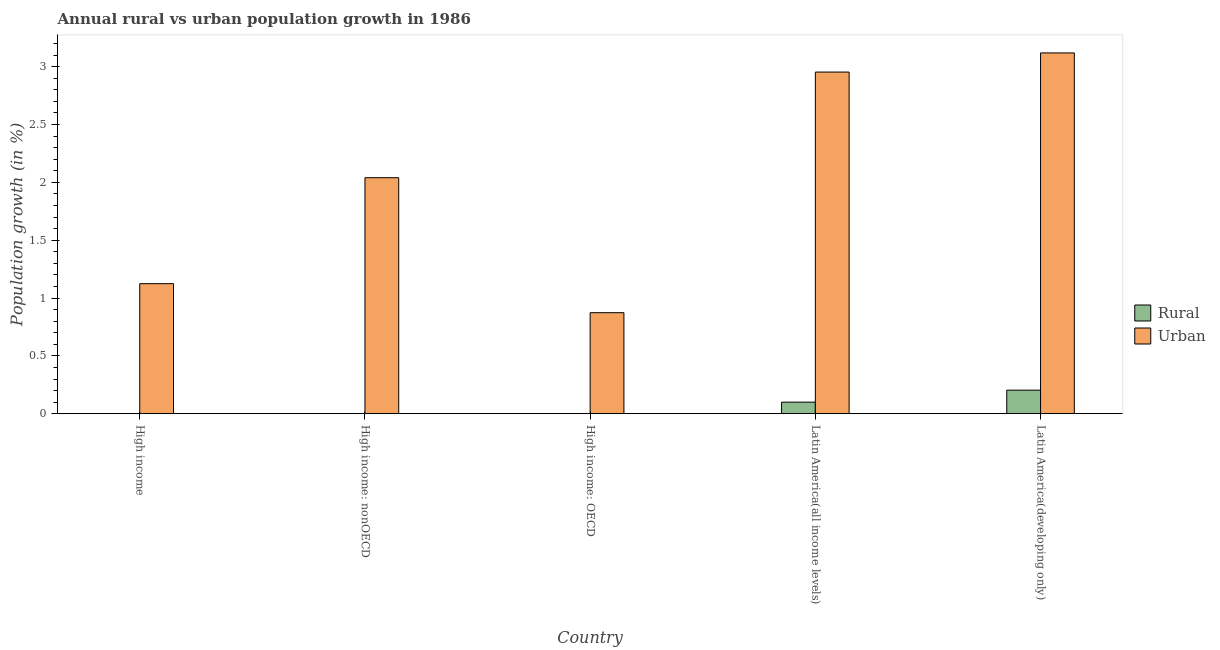How many different coloured bars are there?
Your response must be concise. 2. Are the number of bars on each tick of the X-axis equal?
Make the answer very short. No. How many bars are there on the 3rd tick from the right?
Keep it short and to the point. 1. What is the label of the 4th group of bars from the left?
Your response must be concise. Latin America(all income levels). In how many cases, is the number of bars for a given country not equal to the number of legend labels?
Offer a terse response. 3. What is the rural population growth in High income: OECD?
Offer a very short reply. 0. Across all countries, what is the maximum rural population growth?
Keep it short and to the point. 0.2. Across all countries, what is the minimum urban population growth?
Offer a terse response. 0.87. In which country was the urban population growth maximum?
Your answer should be compact. Latin America(developing only). What is the total rural population growth in the graph?
Your response must be concise. 0.3. What is the difference between the urban population growth in Latin America(all income levels) and that in Latin America(developing only)?
Offer a terse response. -0.17. What is the difference between the rural population growth in Latin America(developing only) and the urban population growth in High income?
Keep it short and to the point. -0.92. What is the average rural population growth per country?
Provide a succinct answer. 0.06. What is the difference between the rural population growth and urban population growth in Latin America(developing only)?
Your answer should be very brief. -2.91. In how many countries, is the urban population growth greater than 1.6 %?
Ensure brevity in your answer.  3. What is the ratio of the urban population growth in Latin America(all income levels) to that in Latin America(developing only)?
Your answer should be very brief. 0.95. Is the urban population growth in High income less than that in Latin America(all income levels)?
Give a very brief answer. Yes. Is the difference between the urban population growth in Latin America(all income levels) and Latin America(developing only) greater than the difference between the rural population growth in Latin America(all income levels) and Latin America(developing only)?
Ensure brevity in your answer.  No. What is the difference between the highest and the second highest urban population growth?
Your answer should be compact. 0.17. What is the difference between the highest and the lowest rural population growth?
Your response must be concise. 0.2. Is the sum of the urban population growth in High income and Latin America(developing only) greater than the maximum rural population growth across all countries?
Ensure brevity in your answer.  Yes. How many bars are there?
Your answer should be compact. 7. Are all the bars in the graph horizontal?
Ensure brevity in your answer.  No. How many countries are there in the graph?
Give a very brief answer. 5. Are the values on the major ticks of Y-axis written in scientific E-notation?
Your response must be concise. No. Does the graph contain grids?
Offer a terse response. No. How many legend labels are there?
Keep it short and to the point. 2. How are the legend labels stacked?
Your response must be concise. Vertical. What is the title of the graph?
Offer a very short reply. Annual rural vs urban population growth in 1986. Does "Electricity" appear as one of the legend labels in the graph?
Provide a succinct answer. No. What is the label or title of the Y-axis?
Keep it short and to the point. Population growth (in %). What is the Population growth (in %) of Rural in High income?
Make the answer very short. 0. What is the Population growth (in %) of Urban  in High income?
Provide a succinct answer. 1.12. What is the Population growth (in %) in Urban  in High income: nonOECD?
Keep it short and to the point. 2.04. What is the Population growth (in %) of Urban  in High income: OECD?
Offer a terse response. 0.87. What is the Population growth (in %) in Rural in Latin America(all income levels)?
Offer a very short reply. 0.1. What is the Population growth (in %) of Urban  in Latin America(all income levels)?
Your answer should be very brief. 2.95. What is the Population growth (in %) of Rural in Latin America(developing only)?
Your answer should be compact. 0.2. What is the Population growth (in %) in Urban  in Latin America(developing only)?
Give a very brief answer. 3.12. Across all countries, what is the maximum Population growth (in %) of Rural?
Offer a terse response. 0.2. Across all countries, what is the maximum Population growth (in %) of Urban ?
Offer a terse response. 3.12. Across all countries, what is the minimum Population growth (in %) in Urban ?
Your answer should be compact. 0.87. What is the total Population growth (in %) in Rural in the graph?
Your answer should be compact. 0.3. What is the total Population growth (in %) of Urban  in the graph?
Give a very brief answer. 10.11. What is the difference between the Population growth (in %) of Urban  in High income and that in High income: nonOECD?
Your answer should be very brief. -0.92. What is the difference between the Population growth (in %) of Urban  in High income and that in High income: OECD?
Keep it short and to the point. 0.25. What is the difference between the Population growth (in %) in Urban  in High income and that in Latin America(all income levels)?
Offer a very short reply. -1.83. What is the difference between the Population growth (in %) in Urban  in High income and that in Latin America(developing only)?
Provide a short and direct response. -1.99. What is the difference between the Population growth (in %) in Urban  in High income: nonOECD and that in High income: OECD?
Offer a terse response. 1.17. What is the difference between the Population growth (in %) of Urban  in High income: nonOECD and that in Latin America(all income levels)?
Your answer should be very brief. -0.91. What is the difference between the Population growth (in %) in Urban  in High income: nonOECD and that in Latin America(developing only)?
Provide a short and direct response. -1.08. What is the difference between the Population growth (in %) of Urban  in High income: OECD and that in Latin America(all income levels)?
Provide a succinct answer. -2.08. What is the difference between the Population growth (in %) in Urban  in High income: OECD and that in Latin America(developing only)?
Your response must be concise. -2.25. What is the difference between the Population growth (in %) in Rural in Latin America(all income levels) and that in Latin America(developing only)?
Make the answer very short. -0.1. What is the difference between the Population growth (in %) in Urban  in Latin America(all income levels) and that in Latin America(developing only)?
Keep it short and to the point. -0.17. What is the difference between the Population growth (in %) of Rural in Latin America(all income levels) and the Population growth (in %) of Urban  in Latin America(developing only)?
Give a very brief answer. -3.02. What is the average Population growth (in %) in Rural per country?
Give a very brief answer. 0.06. What is the average Population growth (in %) in Urban  per country?
Keep it short and to the point. 2.02. What is the difference between the Population growth (in %) of Rural and Population growth (in %) of Urban  in Latin America(all income levels)?
Your answer should be very brief. -2.85. What is the difference between the Population growth (in %) in Rural and Population growth (in %) in Urban  in Latin America(developing only)?
Make the answer very short. -2.92. What is the ratio of the Population growth (in %) in Urban  in High income to that in High income: nonOECD?
Give a very brief answer. 0.55. What is the ratio of the Population growth (in %) of Urban  in High income to that in High income: OECD?
Ensure brevity in your answer.  1.29. What is the ratio of the Population growth (in %) of Urban  in High income to that in Latin America(all income levels)?
Your response must be concise. 0.38. What is the ratio of the Population growth (in %) in Urban  in High income to that in Latin America(developing only)?
Provide a short and direct response. 0.36. What is the ratio of the Population growth (in %) in Urban  in High income: nonOECD to that in High income: OECD?
Make the answer very short. 2.34. What is the ratio of the Population growth (in %) of Urban  in High income: nonOECD to that in Latin America(all income levels)?
Your answer should be compact. 0.69. What is the ratio of the Population growth (in %) of Urban  in High income: nonOECD to that in Latin America(developing only)?
Offer a terse response. 0.65. What is the ratio of the Population growth (in %) in Urban  in High income: OECD to that in Latin America(all income levels)?
Ensure brevity in your answer.  0.3. What is the ratio of the Population growth (in %) in Urban  in High income: OECD to that in Latin America(developing only)?
Make the answer very short. 0.28. What is the ratio of the Population growth (in %) in Rural in Latin America(all income levels) to that in Latin America(developing only)?
Your response must be concise. 0.49. What is the ratio of the Population growth (in %) of Urban  in Latin America(all income levels) to that in Latin America(developing only)?
Your response must be concise. 0.95. What is the difference between the highest and the second highest Population growth (in %) in Urban ?
Your answer should be compact. 0.17. What is the difference between the highest and the lowest Population growth (in %) of Rural?
Your answer should be compact. 0.2. What is the difference between the highest and the lowest Population growth (in %) in Urban ?
Your response must be concise. 2.25. 